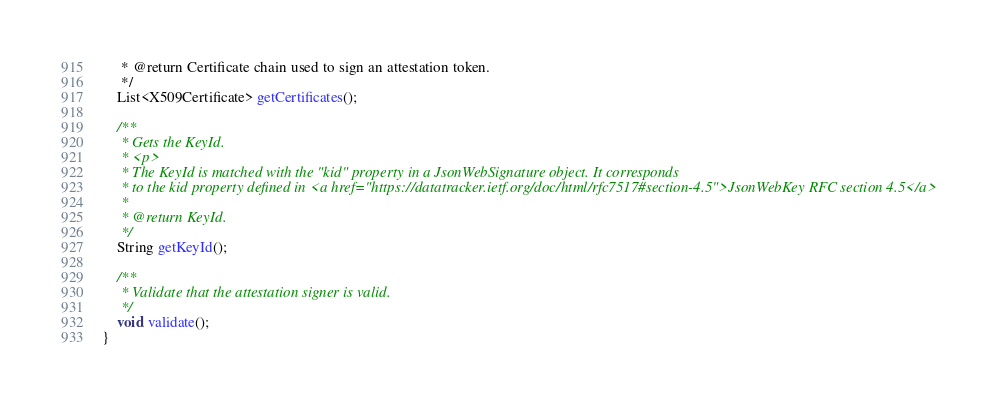Convert code to text. <code><loc_0><loc_0><loc_500><loc_500><_Java_>     * @return Certificate chain used to sign an attestation token.
     */
    List<X509Certificate> getCertificates();

    /**
     * Gets the KeyId.
     * <p>
     * The KeyId is matched with the "kid" property in a JsonWebSignature object. It corresponds
     * to the kid property defined in <a href="https://datatracker.ietf.org/doc/html/rfc7517#section-4.5">JsonWebKey RFC section 4.5</a>
     *
     * @return KeyId.
     */
    String getKeyId();

    /**
     * Validate that the attestation signer is valid.
     */
    void validate();
}
</code> 